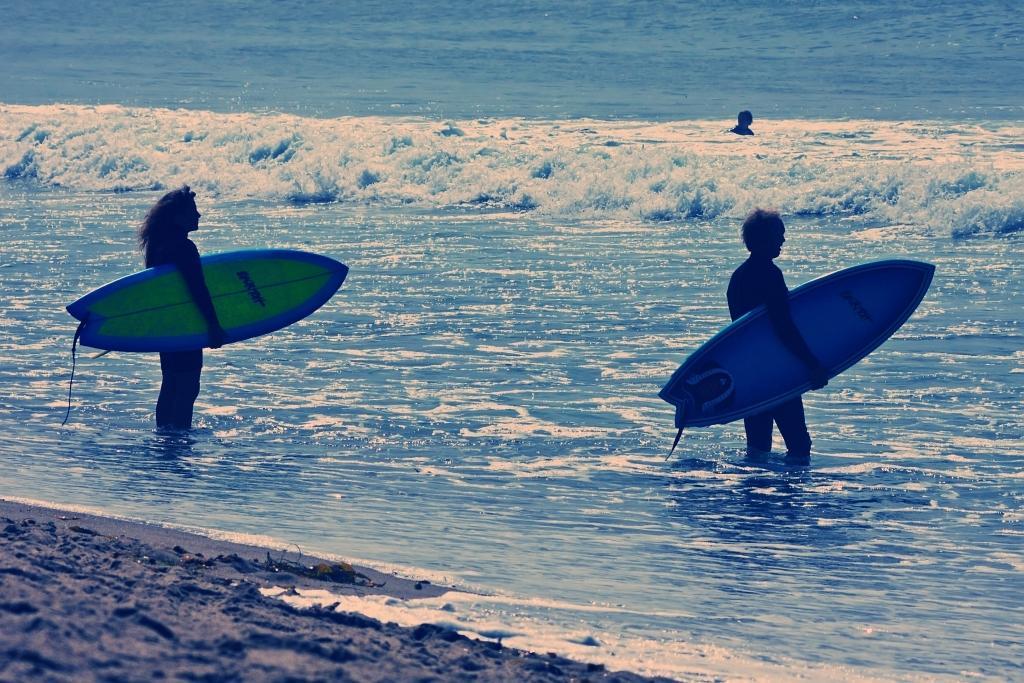Could you give a brief overview of what you see in this image? In this image we can see three people, two of them are holding the surfboards and standing in the sea, there are some objects on the ground. 